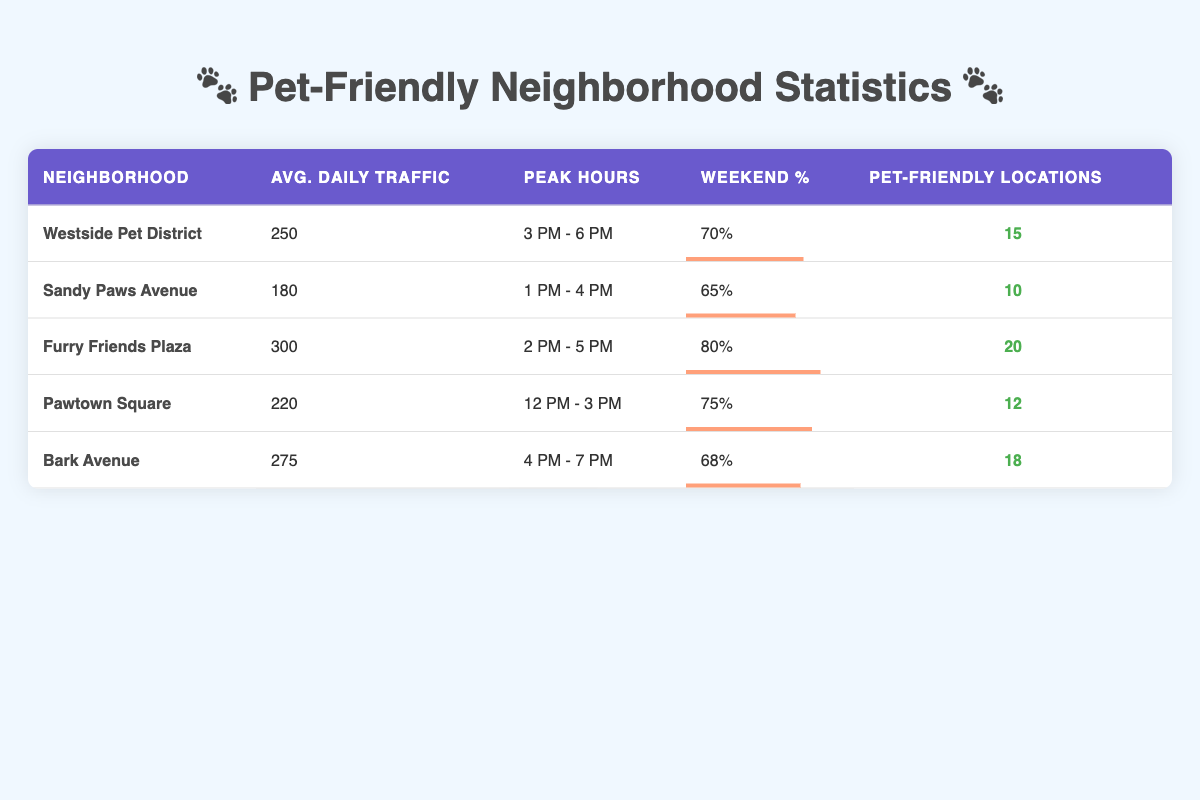What is the average daily traffic for Furry Friends Plaza? The average daily traffic for Furry Friends Plaza is explicitly listed in the table as 300.
Answer: 300 Which neighborhood has the highest weekend percentage? The weekend percentage values for each neighborhood are compared: 70% for Westside Pet District, 65% for Sandy Paws Avenue, 80% for Furry Friends Plaza, 75% for Pawtown Square, and 68% for Bark Avenue. Furry Friends Plaza has the highest at 80%.
Answer: Furry Friends Plaza Is the average daily traffic for Pawtown Square greater than 250? The average daily traffic for Pawtown Square is 220, which is less than 250.
Answer: No How many pet-friendly locations does Bark Avenue have compared to Sandy Paws Avenue? Bark Avenue has 18 pet-friendly locations, while Sandy Paws Avenue has 10. The difference is 18 - 10 = 8 more locations.
Answer: 8 Calculate the total average daily traffic across all neighborhoods. The total average daily traffic is calculated by summing the average daily traffic for all neighborhoods: 250 + 180 + 300 + 220 + 275 = 1225. There are 5 neighborhoods, so the average is 1225 / 5 = 245.
Answer: 245 Which neighborhood has the earliest peak hours? The peak hours for each neighborhood are analyzed: Westside Pet District (3 PM - 6 PM), Sandy Paws Avenue (1 PM - 4 PM), Furry Friends Plaza (2 PM - 5 PM), Pawtown Square (12 PM - 3 PM), and Bark Avenue (4 PM - 7 PM). Pawtown Square has the earliest peak hours starting at 12 PM.
Answer: Pawtown Square Is there a neighborhood with at least 15 pet-friendly locations and a weekend percentage over 75%? The neighborhoods with at least 15 pet-friendly locations are Westside Pet District (15), Furry Friends Plaza (20), and Bark Avenue (18). Among these, only Furry Friends Plaza has a weekend percentage over 75% (which is 80%).
Answer: Yes What is the average weekend percentage for all neighborhoods? The average weekend percentage is calculated by adding the weekend percentages: 70 + 65 + 80 + 75 + 68 = 358. Then divide by the number of neighborhoods (5) to get 358 / 5 = 71.6.
Answer: 71.6 Which neighborhood has the lowest average daily traffic? A comparison of the average daily traffic for each neighborhood shows that Sandy Paws Avenue has the lowest at 180.
Answer: Sandy Paws Avenue 